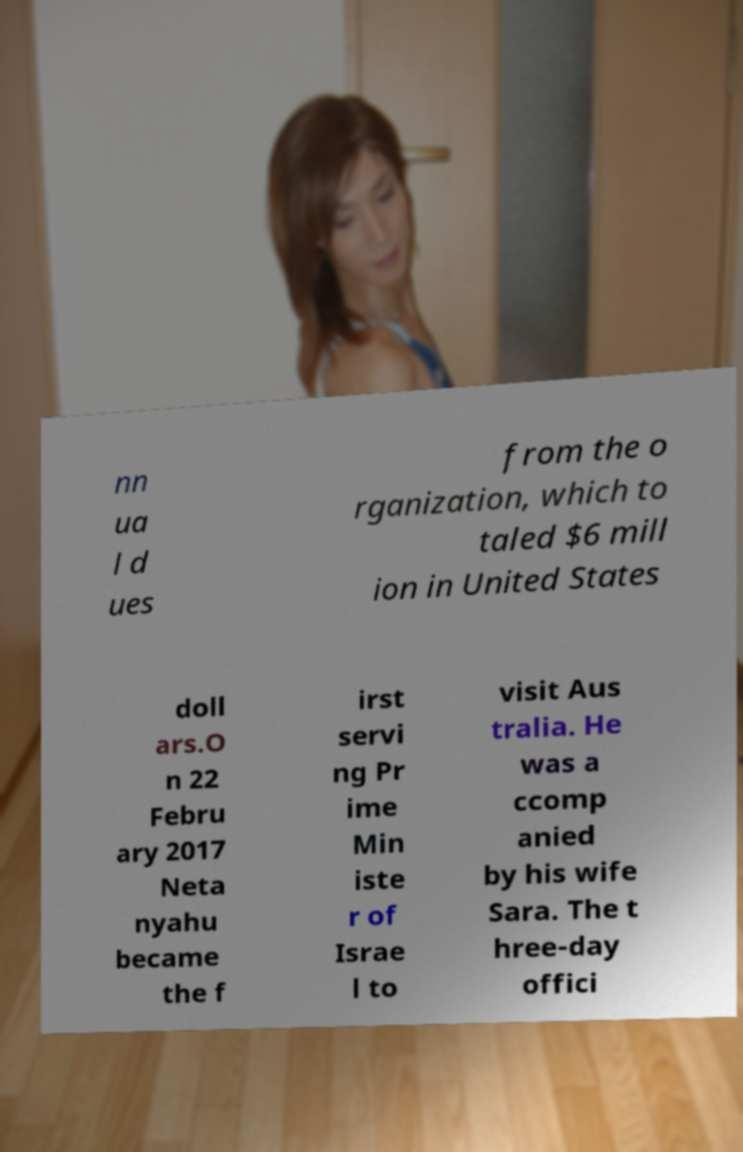Can you read and provide the text displayed in the image?This photo seems to have some interesting text. Can you extract and type it out for me? nn ua l d ues from the o rganization, which to taled $6 mill ion in United States doll ars.O n 22 Febru ary 2017 Neta nyahu became the f irst servi ng Pr ime Min iste r of Israe l to visit Aus tralia. He was a ccomp anied by his wife Sara. The t hree-day offici 